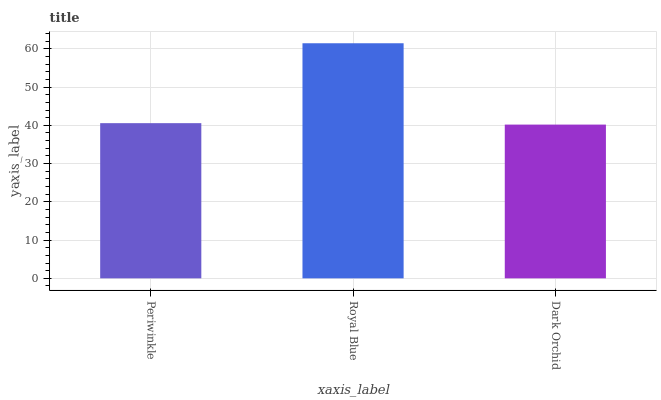Is Dark Orchid the minimum?
Answer yes or no. Yes. Is Royal Blue the maximum?
Answer yes or no. Yes. Is Royal Blue the minimum?
Answer yes or no. No. Is Dark Orchid the maximum?
Answer yes or no. No. Is Royal Blue greater than Dark Orchid?
Answer yes or no. Yes. Is Dark Orchid less than Royal Blue?
Answer yes or no. Yes. Is Dark Orchid greater than Royal Blue?
Answer yes or no. No. Is Royal Blue less than Dark Orchid?
Answer yes or no. No. Is Periwinkle the high median?
Answer yes or no. Yes. Is Periwinkle the low median?
Answer yes or no. Yes. Is Royal Blue the high median?
Answer yes or no. No. Is Royal Blue the low median?
Answer yes or no. No. 